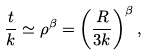<formula> <loc_0><loc_0><loc_500><loc_500>\frac { t } { k } \simeq \rho ^ { \beta } = \left ( \frac { R } { 3 k } \right ) ^ { \beta } ,</formula> 